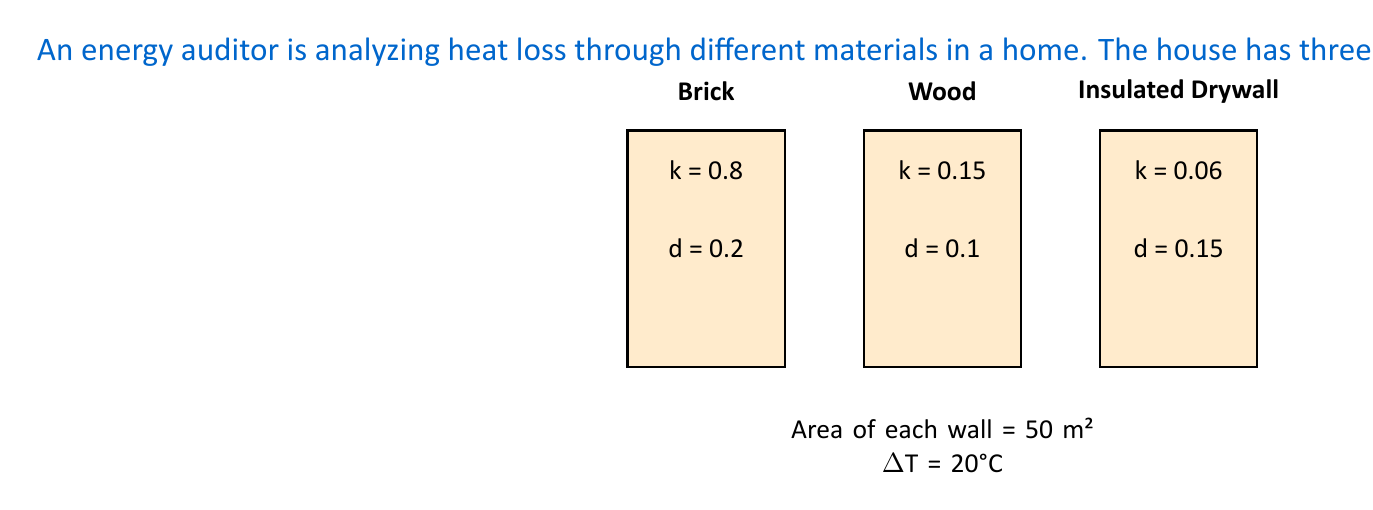Can you answer this question? To solve this problem, we'll use Fourier's Law of Heat Conduction for each wall and then sum the results. The formula is:

$$Q = \frac{k A \Delta T}{d}$$

Where:
$Q$ = Heat transfer rate (W)
$k$ = Thermal conductivity (W/m·K)
$A$ = Area (m²)
$\Delta T$ = Temperature difference (°C or K)
$d$ = Thickness (m)

Let's calculate for each wall:

1. Brick wall:
   $$Q_{brick} = \frac{0.8 \cdot 50 \cdot 20}{0.2} = 4000 \text{ W}$$

2. Wood wall:
   $$Q_{wood} = \frac{0.15 \cdot 50 \cdot 20}{0.1} = 1500 \text{ W}$$

3. Insulated Drywall:
   $$Q_{drywall} = \frac{0.06 \cdot 50 \cdot 20}{0.15} = 400 \text{ W}$$

Now, we sum up the heat loss through all three walls:

$$Q_{total} = Q_{brick} + Q_{wood} + Q_{drywall}$$
$$Q_{total} = 4000 + 1500 + 400 = 5900 \text{ W}$$
Answer: 5900 W 